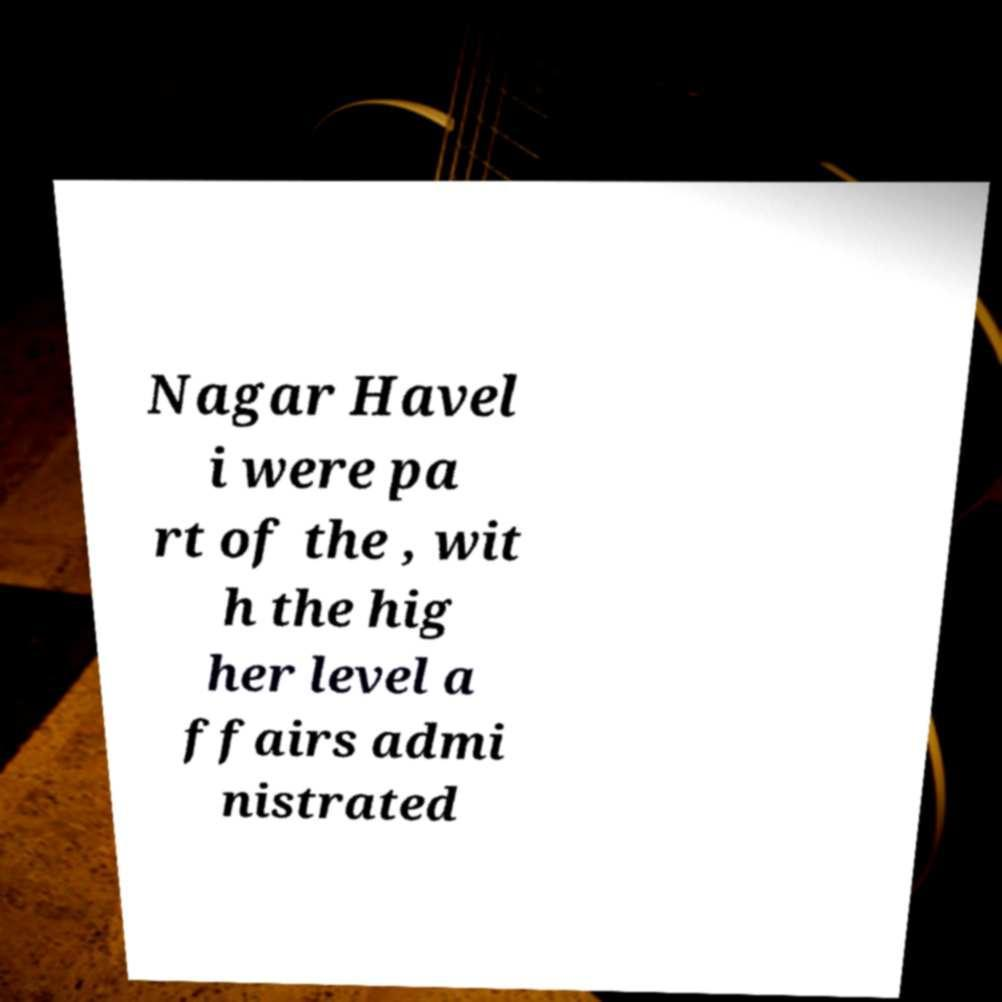Could you extract and type out the text from this image? Nagar Havel i were pa rt of the , wit h the hig her level a ffairs admi nistrated 